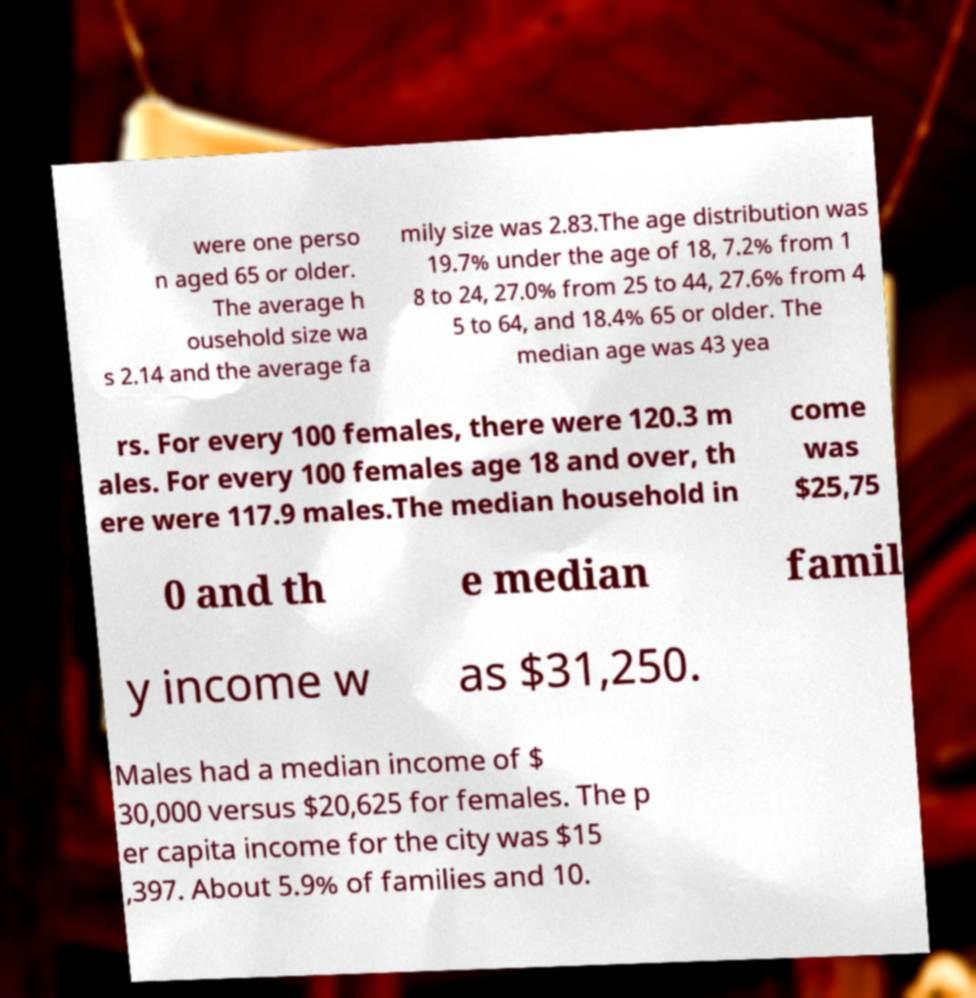Could you assist in decoding the text presented in this image and type it out clearly? were one perso n aged 65 or older. The average h ousehold size wa s 2.14 and the average fa mily size was 2.83.The age distribution was 19.7% under the age of 18, 7.2% from 1 8 to 24, 27.0% from 25 to 44, 27.6% from 4 5 to 64, and 18.4% 65 or older. The median age was 43 yea rs. For every 100 females, there were 120.3 m ales. For every 100 females age 18 and over, th ere were 117.9 males.The median household in come was $25,75 0 and th e median famil y income w as $31,250. Males had a median income of $ 30,000 versus $20,625 for females. The p er capita income for the city was $15 ,397. About 5.9% of families and 10. 